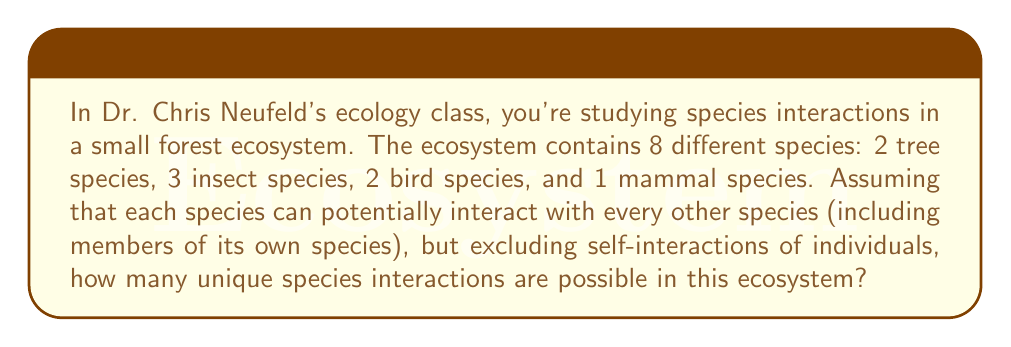Teach me how to tackle this problem. Let's approach this step-by-step:

1) First, we need to understand what we're counting. We're looking for the number of unique pairs of species, including interactions within the same species (but not self-interactions of individuals).

2) This is a combination problem. We can use the combination formula with repetition, as we're allowing interactions within the same species.

3) The formula for combinations with repetition is:

   $${n+r-1 \choose r}$$

   Where $n$ is the number of types to choose from (in this case, species), and $r$ is the number of items being chosen (in this case, 2, as we're looking at pairs of species).

4) In our problem:
   $n = 8$ (total number of species)
   $r = 2$ (we're looking at pairs)

5) Plugging these into our formula:

   $${8+2-1 \choose 2} = {9 \choose 2}$$

6) We can calculate this:

   $$\frac{9!}{2!(9-2)!} = \frac{9!}{2!(7)!} = \frac{9 * 8}{2 * 1} = 36$$

Therefore, there are 36 possible unique species interactions in this ecosystem.
Answer: 36 unique species interactions 